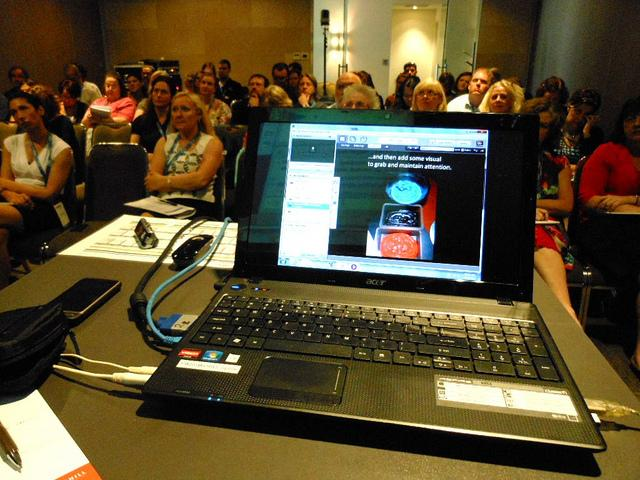What is the purpose of this event? conference 